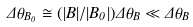<formula> <loc_0><loc_0><loc_500><loc_500>\Delta \theta _ { B _ { 0 } } \cong ( | B | / | B _ { 0 } | ) \Delta \theta _ { B } \ll \Delta \theta _ { B }</formula> 